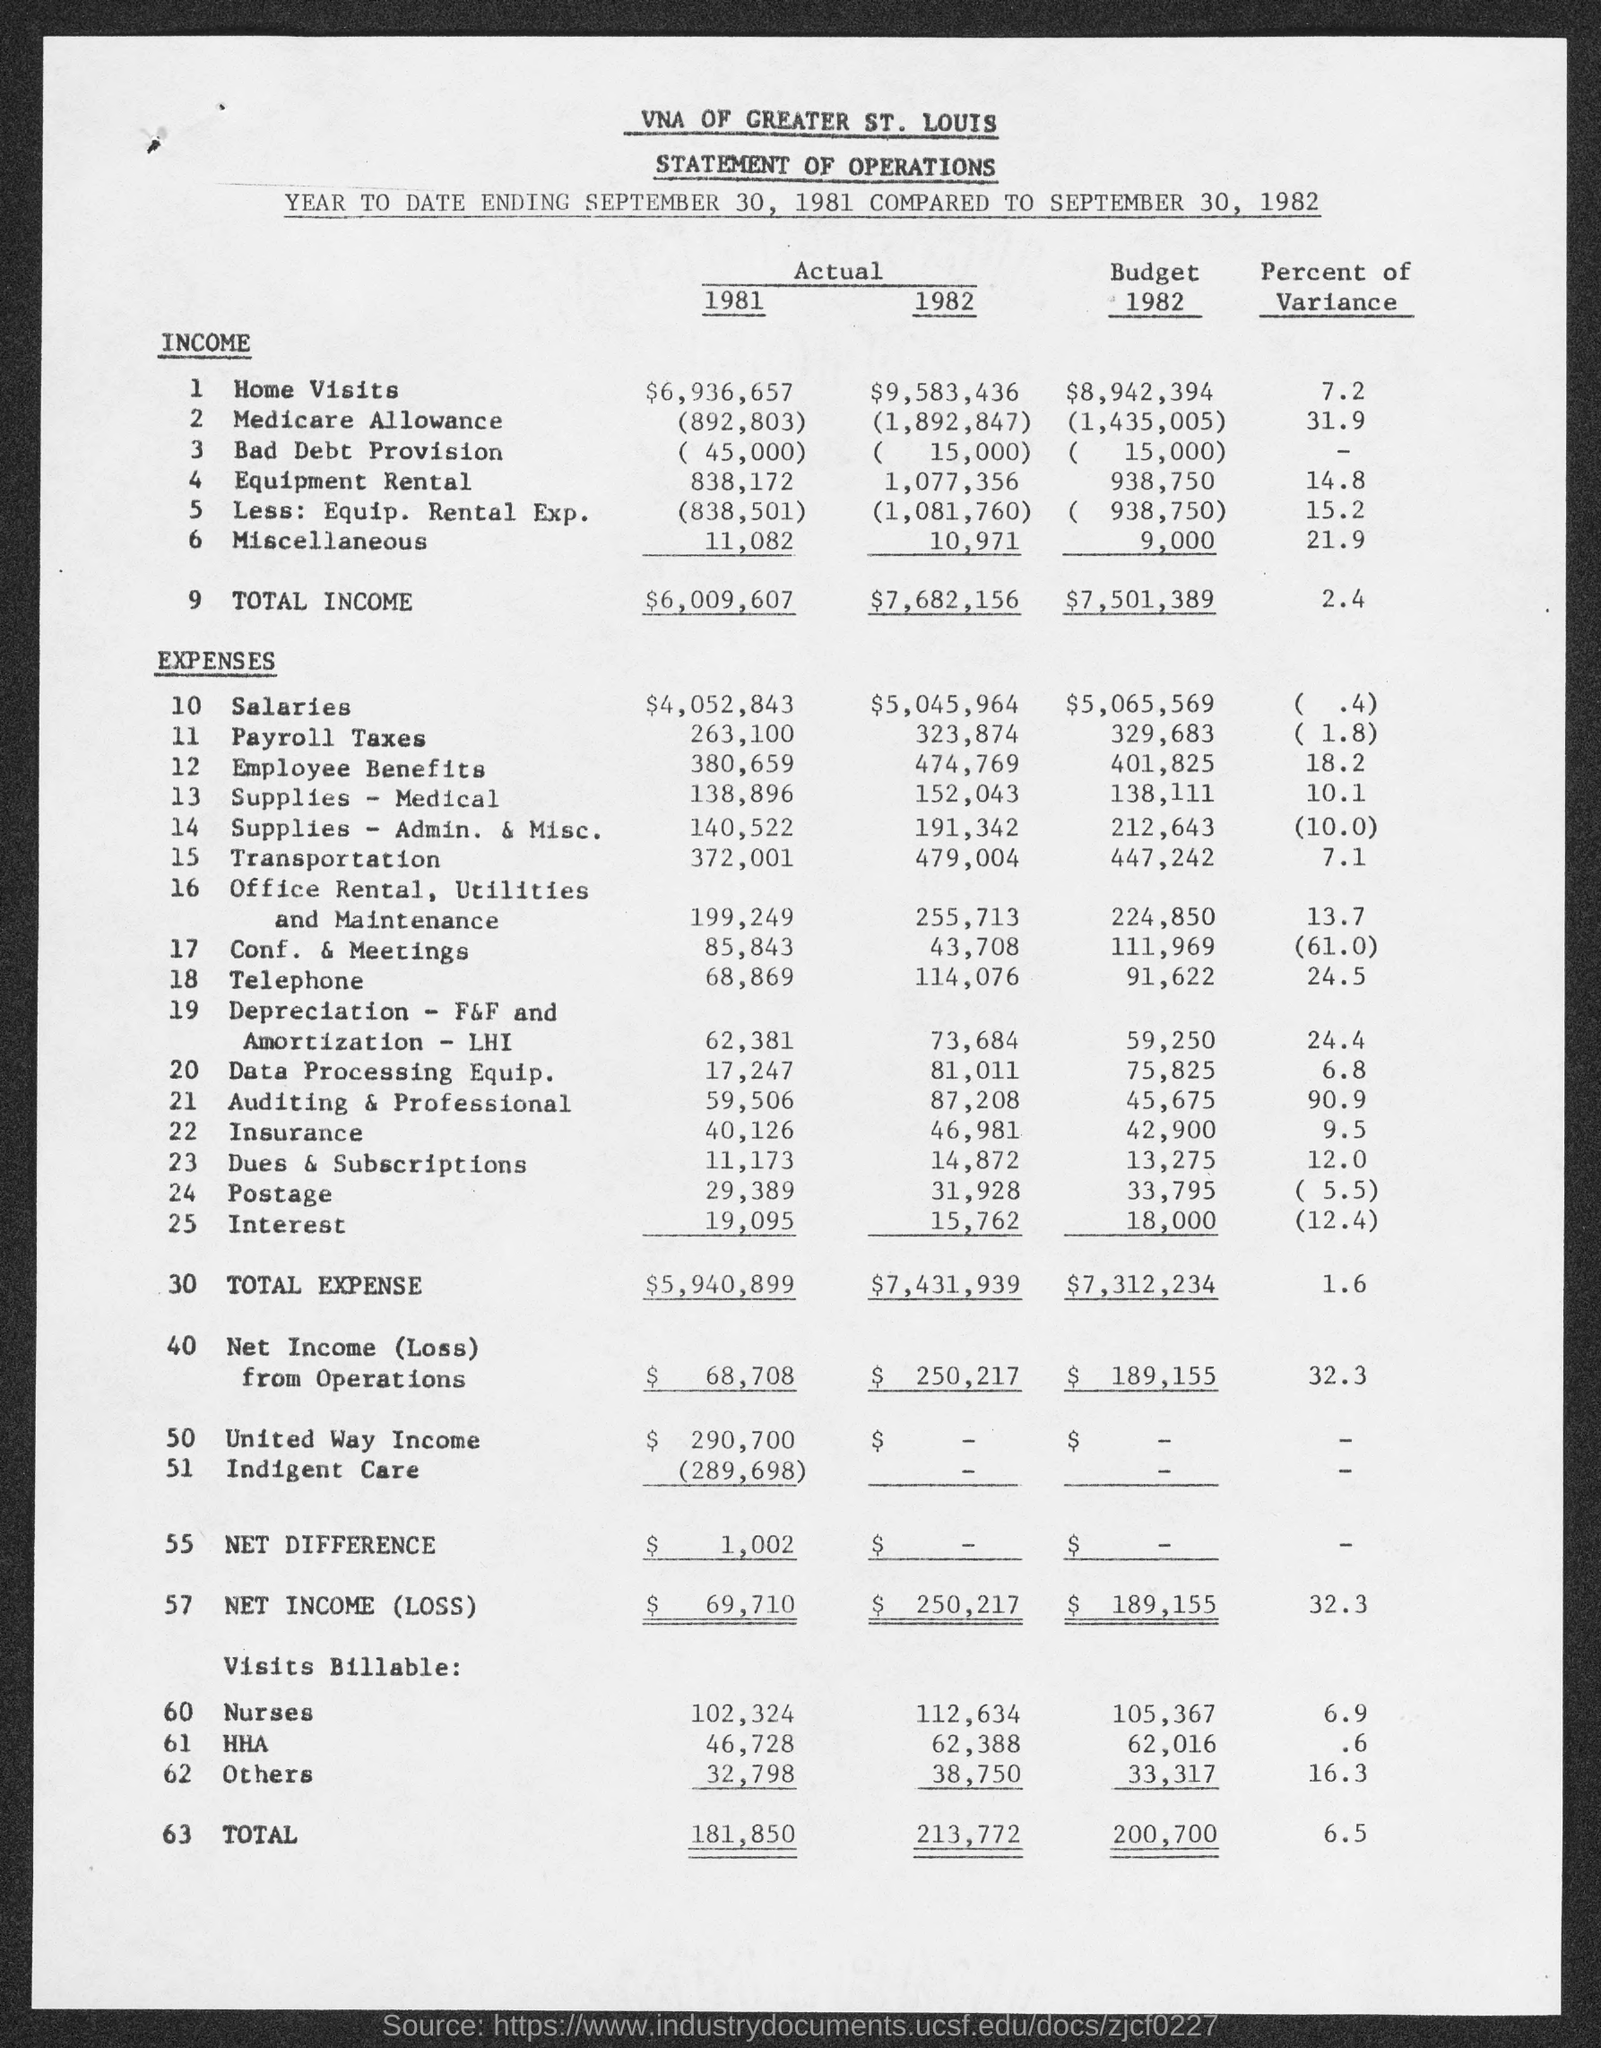Indicate a few pertinent items in this graphic. The total income corresponding to the year 1981, as stated in the title "Actual," is $6,009,607. The percent of variance for others is 16.3.. 